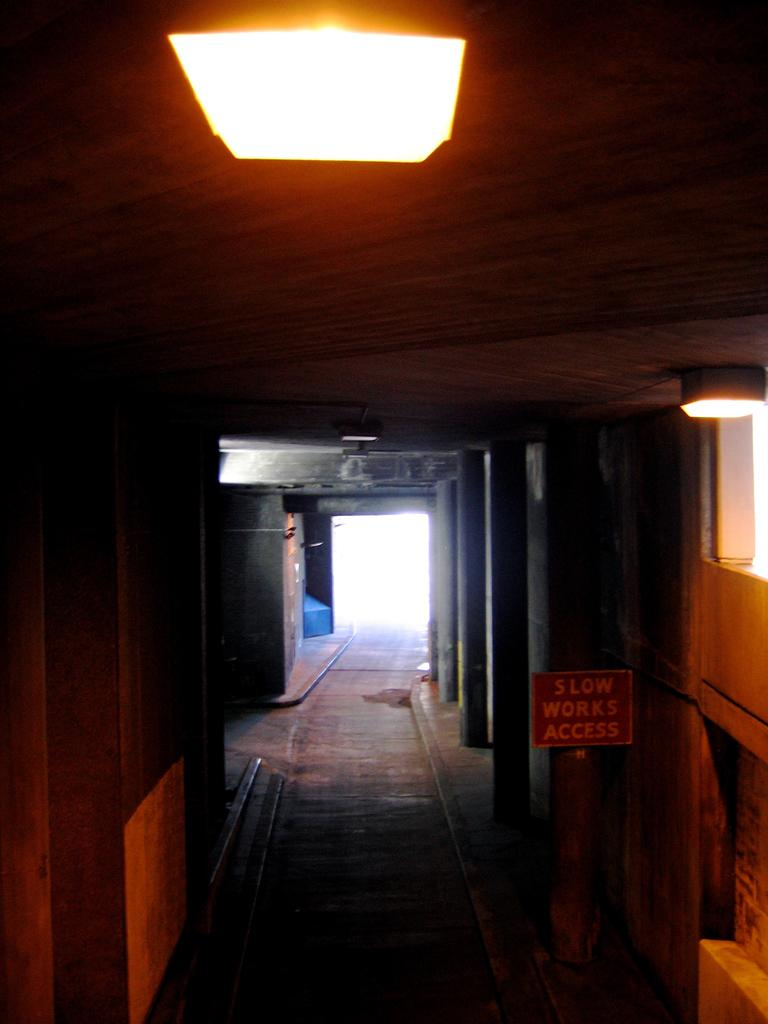What is a prominent feature in the image? There is a door in the image. Can you describe any other objects in the image? There are lamps on the roof in the image. What type of plantation can be seen in the image? There is no plantation present in the image; it only features a door and lamps on the roof. What kind of experience can be gained from the image? The image itself is a visual experience, but it does not convey any specific experiences or emotions. 